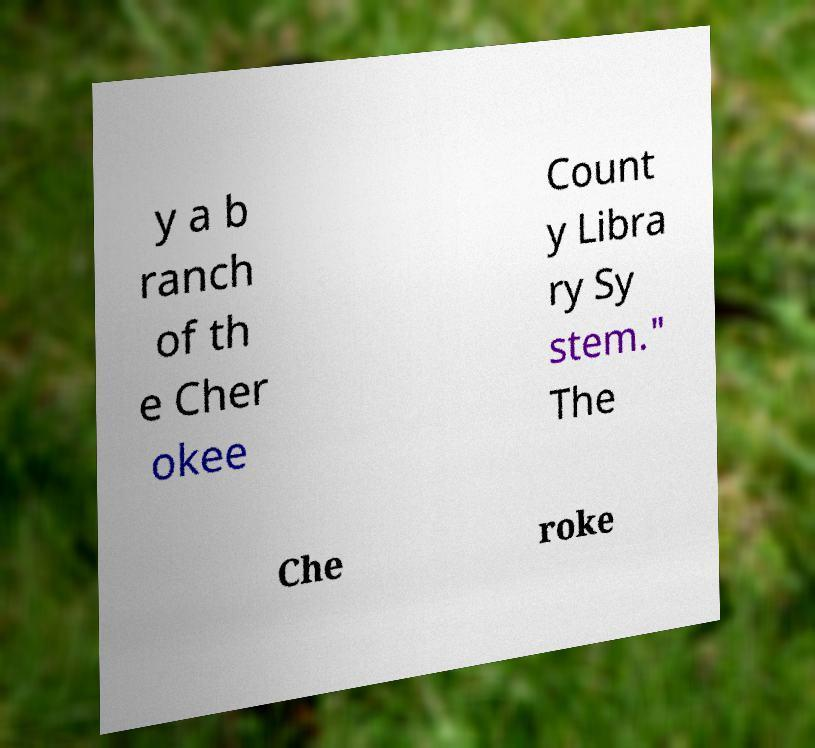Could you extract and type out the text from this image? y a b ranch of th e Cher okee Count y Libra ry Sy stem." The Che roke 